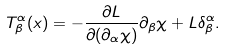<formula> <loc_0><loc_0><loc_500><loc_500>T _ { \beta } ^ { \alpha } ( x ) = - \frac { \partial L } { \partial ( \partial _ { \alpha } \chi ) } \partial _ { \beta } \chi + L \delta _ { \beta } ^ { \alpha } .</formula> 